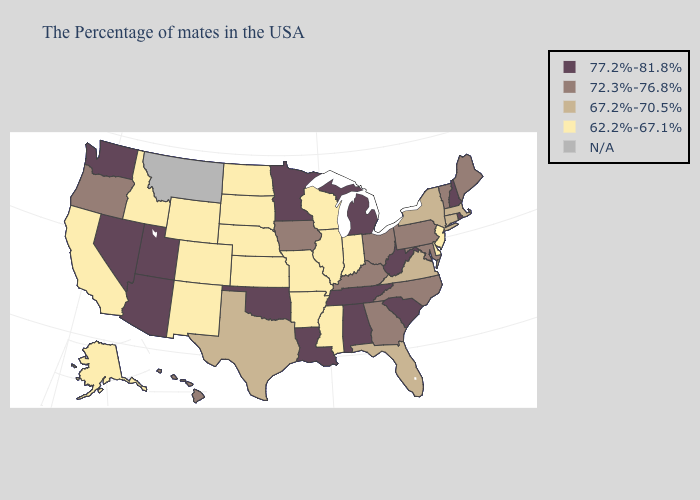What is the highest value in states that border New Mexico?
Concise answer only. 77.2%-81.8%. What is the highest value in the MidWest ?
Answer briefly. 77.2%-81.8%. Name the states that have a value in the range 62.2%-67.1%?
Write a very short answer. New Jersey, Delaware, Indiana, Wisconsin, Illinois, Mississippi, Missouri, Arkansas, Kansas, Nebraska, South Dakota, North Dakota, Wyoming, Colorado, New Mexico, Idaho, California, Alaska. Does Mississippi have the lowest value in the South?
Concise answer only. Yes. Which states have the lowest value in the USA?
Concise answer only. New Jersey, Delaware, Indiana, Wisconsin, Illinois, Mississippi, Missouri, Arkansas, Kansas, Nebraska, South Dakota, North Dakota, Wyoming, Colorado, New Mexico, Idaho, California, Alaska. Name the states that have a value in the range 62.2%-67.1%?
Concise answer only. New Jersey, Delaware, Indiana, Wisconsin, Illinois, Mississippi, Missouri, Arkansas, Kansas, Nebraska, South Dakota, North Dakota, Wyoming, Colorado, New Mexico, Idaho, California, Alaska. Name the states that have a value in the range N/A?
Give a very brief answer. Montana. Name the states that have a value in the range 77.2%-81.8%?
Answer briefly. Rhode Island, New Hampshire, South Carolina, West Virginia, Michigan, Alabama, Tennessee, Louisiana, Minnesota, Oklahoma, Utah, Arizona, Nevada, Washington. What is the lowest value in the USA?
Write a very short answer. 62.2%-67.1%. Name the states that have a value in the range 67.2%-70.5%?
Be succinct. Massachusetts, Connecticut, New York, Virginia, Florida, Texas. How many symbols are there in the legend?
Give a very brief answer. 5. What is the value of North Carolina?
Answer briefly. 72.3%-76.8%. Does the first symbol in the legend represent the smallest category?
Short answer required. No. What is the value of North Carolina?
Keep it brief. 72.3%-76.8%. Does Wisconsin have the lowest value in the USA?
Give a very brief answer. Yes. 